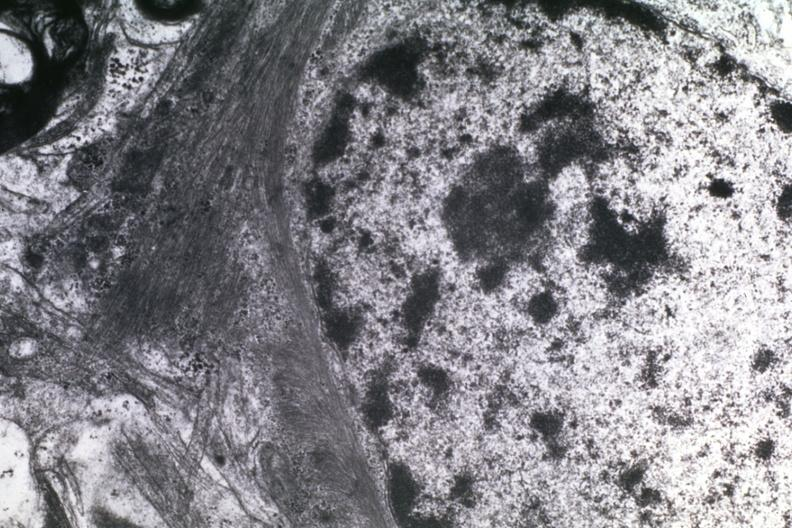does benign cystic teratoma show dr garcia tumors 15?
Answer the question using a single word or phrase. No 